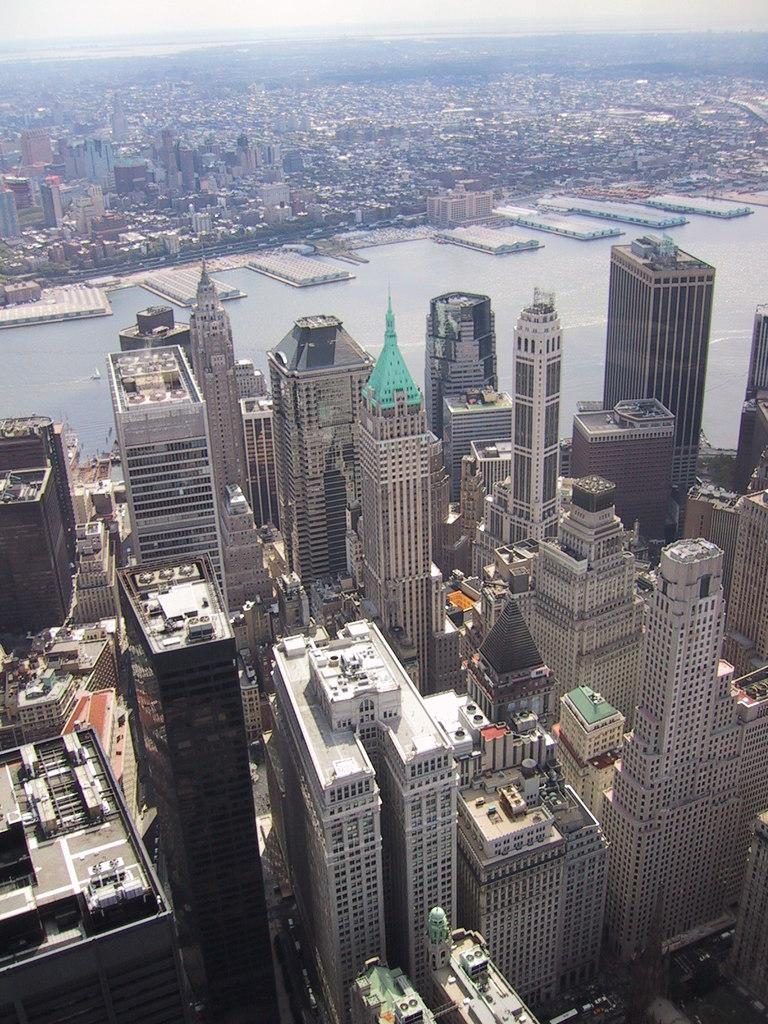What is the main feature in the foreground of the image? There are many buildings in the foreground of the image. What can be seen in the middle of the image? There is a water body in the middle of the image. What is visible in the background of the image? There are many buildings in the background of the image. Can you tell me how many cacti are growing near the water body in the image? There is no mention of cacti in the image; the main features are buildings and a water body. Is there a nut floating in the water body in the image? There is no mention of a nut in the image; the main feature is a water body. 